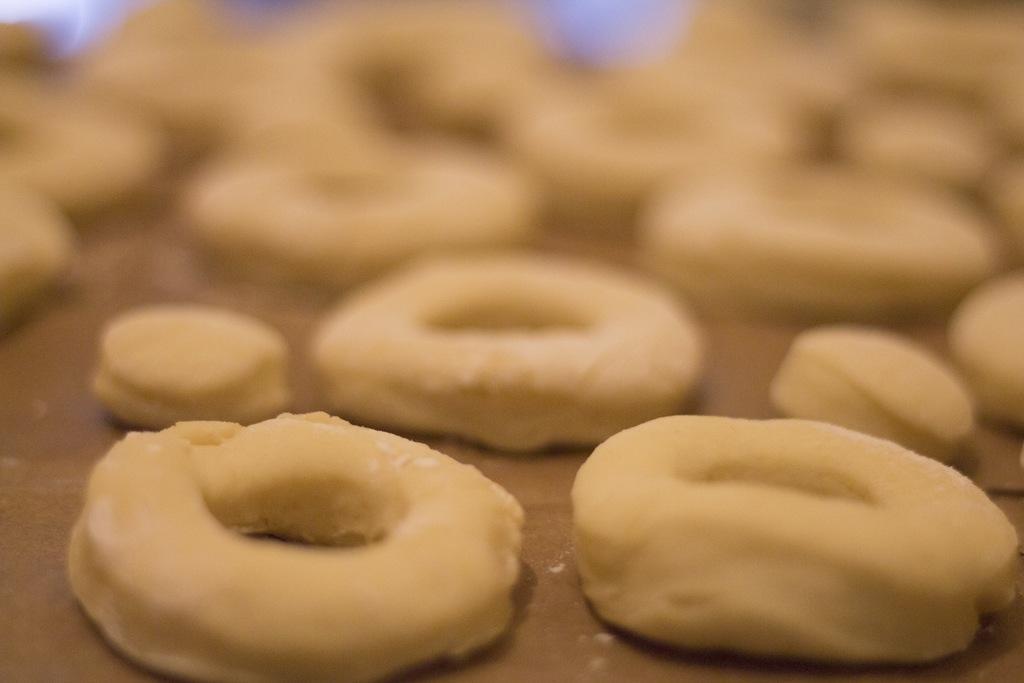Can you describe this image briefly? In this image there are few dough which is in ring shape is kept on the wooden plank. 